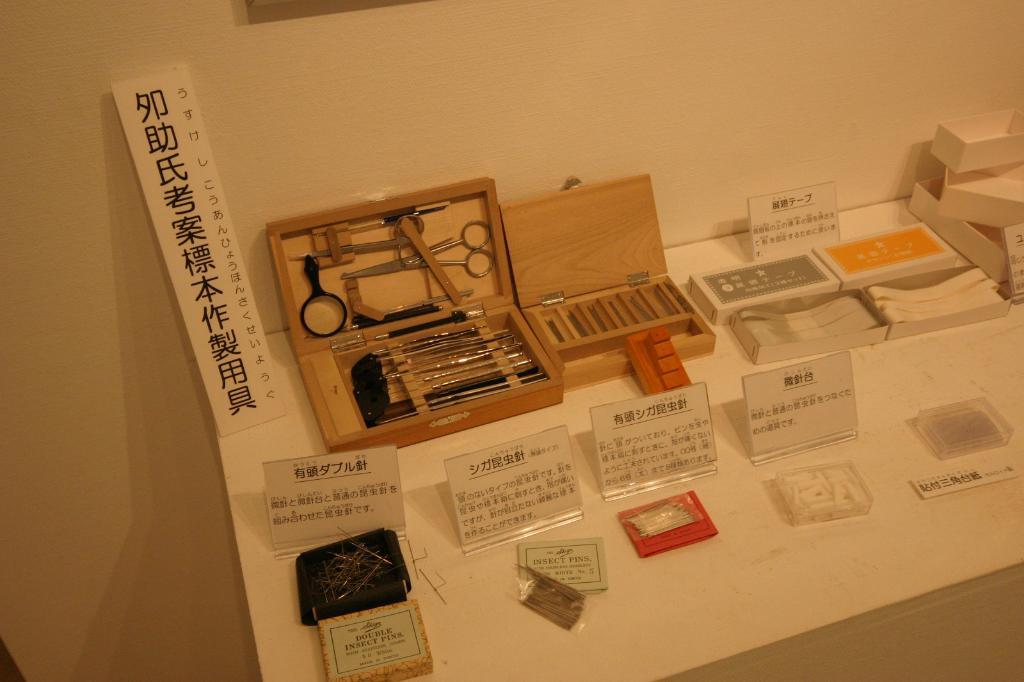<image>
Provide a brief description of the given image. Signs in front of some products including ones that are in Japanese. 